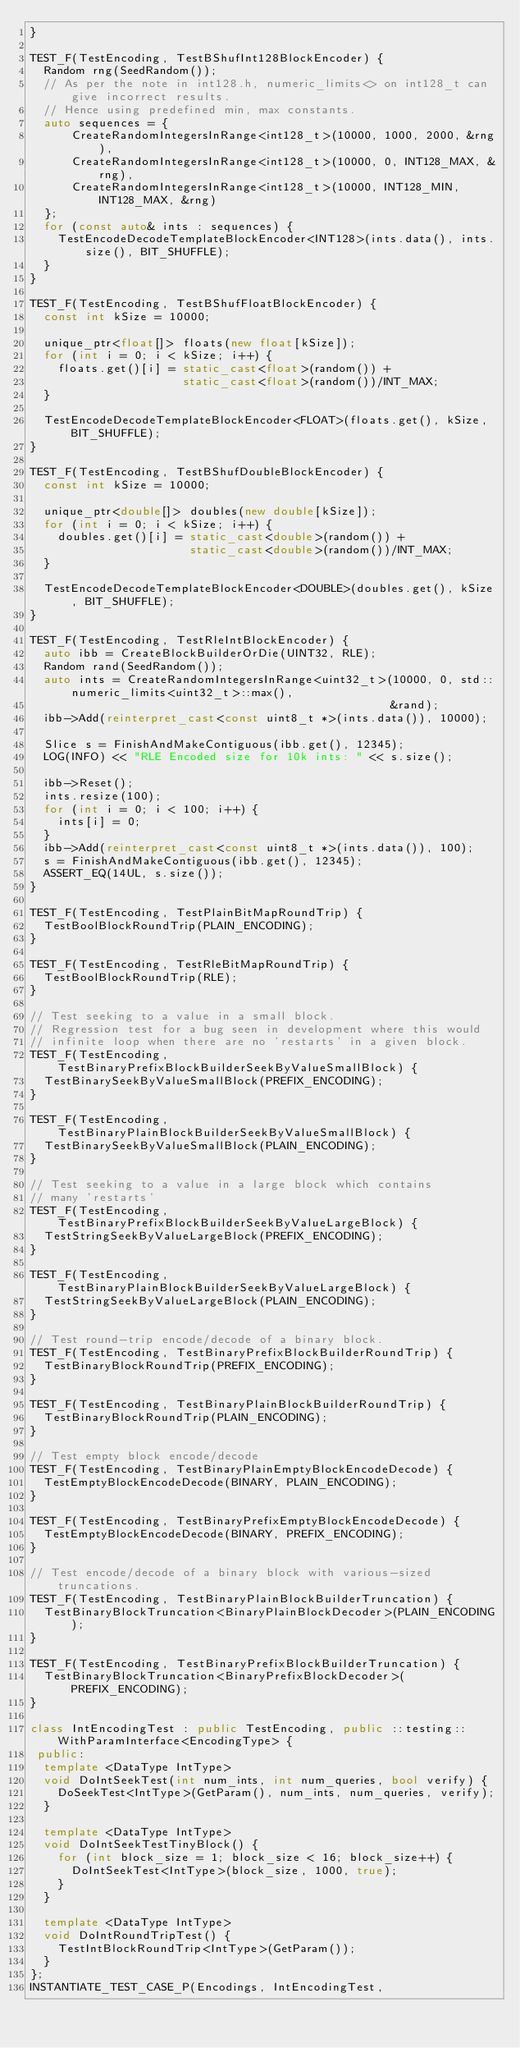<code> <loc_0><loc_0><loc_500><loc_500><_C++_>}

TEST_F(TestEncoding, TestBShufInt128BlockEncoder) {
  Random rng(SeedRandom());
  // As per the note in int128.h, numeric_limits<> on int128_t can give incorrect results.
  // Hence using predefined min, max constants.
  auto sequences = {
      CreateRandomIntegersInRange<int128_t>(10000, 1000, 2000, &rng),
      CreateRandomIntegersInRange<int128_t>(10000, 0, INT128_MAX, &rng),
      CreateRandomIntegersInRange<int128_t>(10000, INT128_MIN, INT128_MAX, &rng)
  };
  for (const auto& ints : sequences) {
    TestEncodeDecodeTemplateBlockEncoder<INT128>(ints.data(), ints.size(), BIT_SHUFFLE);
  }
}

TEST_F(TestEncoding, TestBShufFloatBlockEncoder) {
  const int kSize = 10000;

  unique_ptr<float[]> floats(new float[kSize]);
  for (int i = 0; i < kSize; i++) {
    floats.get()[i] = static_cast<float>(random()) +
                      static_cast<float>(random())/INT_MAX;
  }

  TestEncodeDecodeTemplateBlockEncoder<FLOAT>(floats.get(), kSize, BIT_SHUFFLE);
}

TEST_F(TestEncoding, TestBShufDoubleBlockEncoder) {
  const int kSize = 10000;

  unique_ptr<double[]> doubles(new double[kSize]);
  for (int i = 0; i < kSize; i++) {
    doubles.get()[i] = static_cast<double>(random()) +
                       static_cast<double>(random())/INT_MAX;
  }

  TestEncodeDecodeTemplateBlockEncoder<DOUBLE>(doubles.get(), kSize, BIT_SHUFFLE);
}

TEST_F(TestEncoding, TestRleIntBlockEncoder) {
  auto ibb = CreateBlockBuilderOrDie(UINT32, RLE);
  Random rand(SeedRandom());
  auto ints = CreateRandomIntegersInRange<uint32_t>(10000, 0, std::numeric_limits<uint32_t>::max(),
                                                    &rand);
  ibb->Add(reinterpret_cast<const uint8_t *>(ints.data()), 10000);

  Slice s = FinishAndMakeContiguous(ibb.get(), 12345);
  LOG(INFO) << "RLE Encoded size for 10k ints: " << s.size();

  ibb->Reset();
  ints.resize(100);
  for (int i = 0; i < 100; i++) {
    ints[i] = 0;
  }
  ibb->Add(reinterpret_cast<const uint8_t *>(ints.data()), 100);
  s = FinishAndMakeContiguous(ibb.get(), 12345);
  ASSERT_EQ(14UL, s.size());
}

TEST_F(TestEncoding, TestPlainBitMapRoundTrip) {
  TestBoolBlockRoundTrip(PLAIN_ENCODING);
}

TEST_F(TestEncoding, TestRleBitMapRoundTrip) {
  TestBoolBlockRoundTrip(RLE);
}

// Test seeking to a value in a small block.
// Regression test for a bug seen in development where this would
// infinite loop when there are no 'restarts' in a given block.
TEST_F(TestEncoding, TestBinaryPrefixBlockBuilderSeekByValueSmallBlock) {
  TestBinarySeekByValueSmallBlock(PREFIX_ENCODING);
}

TEST_F(TestEncoding, TestBinaryPlainBlockBuilderSeekByValueSmallBlock) {
  TestBinarySeekByValueSmallBlock(PLAIN_ENCODING);
}

// Test seeking to a value in a large block which contains
// many 'restarts'
TEST_F(TestEncoding, TestBinaryPrefixBlockBuilderSeekByValueLargeBlock) {
  TestStringSeekByValueLargeBlock(PREFIX_ENCODING);
}

TEST_F(TestEncoding, TestBinaryPlainBlockBuilderSeekByValueLargeBlock) {
  TestStringSeekByValueLargeBlock(PLAIN_ENCODING);
}

// Test round-trip encode/decode of a binary block.
TEST_F(TestEncoding, TestBinaryPrefixBlockBuilderRoundTrip) {
  TestBinaryBlockRoundTrip(PREFIX_ENCODING);
}

TEST_F(TestEncoding, TestBinaryPlainBlockBuilderRoundTrip) {
  TestBinaryBlockRoundTrip(PLAIN_ENCODING);
}

// Test empty block encode/decode
TEST_F(TestEncoding, TestBinaryPlainEmptyBlockEncodeDecode) {
  TestEmptyBlockEncodeDecode(BINARY, PLAIN_ENCODING);
}

TEST_F(TestEncoding, TestBinaryPrefixEmptyBlockEncodeDecode) {
  TestEmptyBlockEncodeDecode(BINARY, PREFIX_ENCODING);
}

// Test encode/decode of a binary block with various-sized truncations.
TEST_F(TestEncoding, TestBinaryPlainBlockBuilderTruncation) {
  TestBinaryBlockTruncation<BinaryPlainBlockDecoder>(PLAIN_ENCODING);
}

TEST_F(TestEncoding, TestBinaryPrefixBlockBuilderTruncation) {
  TestBinaryBlockTruncation<BinaryPrefixBlockDecoder>(PREFIX_ENCODING);
}

class IntEncodingTest : public TestEncoding, public ::testing::WithParamInterface<EncodingType> {
 public:
  template <DataType IntType>
  void DoIntSeekTest(int num_ints, int num_queries, bool verify) {
    DoSeekTest<IntType>(GetParam(), num_ints, num_queries, verify);
  }

  template <DataType IntType>
  void DoIntSeekTestTinyBlock() {
    for (int block_size = 1; block_size < 16; block_size++) {
      DoIntSeekTest<IntType>(block_size, 1000, true);
    }
  }

  template <DataType IntType>
  void DoIntRoundTripTest() {
    TestIntBlockRoundTrip<IntType>(GetParam());
  }
};
INSTANTIATE_TEST_CASE_P(Encodings, IntEncodingTest,</code> 